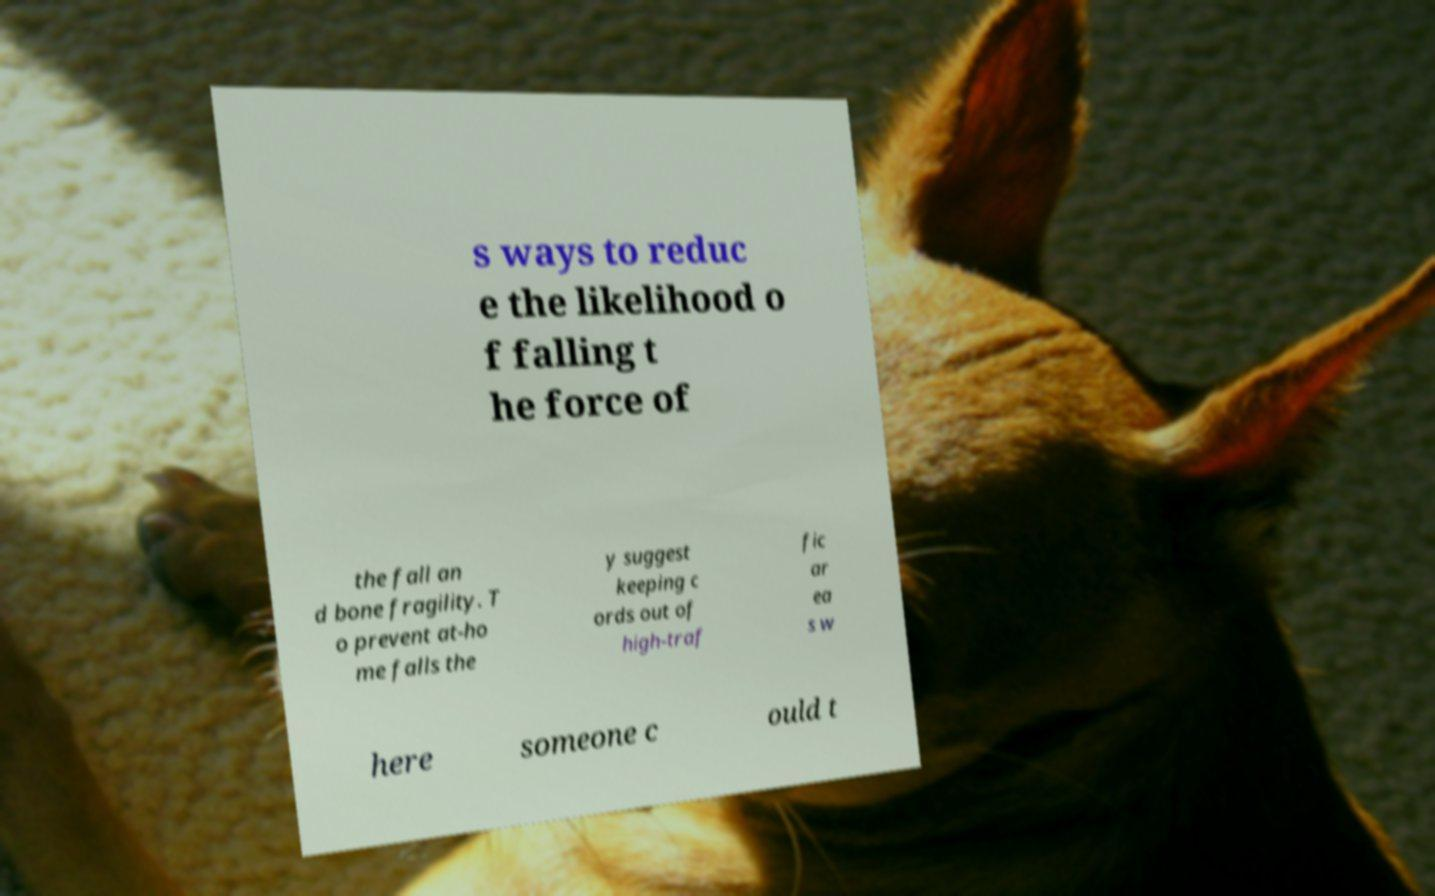What messages or text are displayed in this image? I need them in a readable, typed format. s ways to reduc e the likelihood o f falling t he force of the fall an d bone fragility. T o prevent at-ho me falls the y suggest keeping c ords out of high-traf fic ar ea s w here someone c ould t 